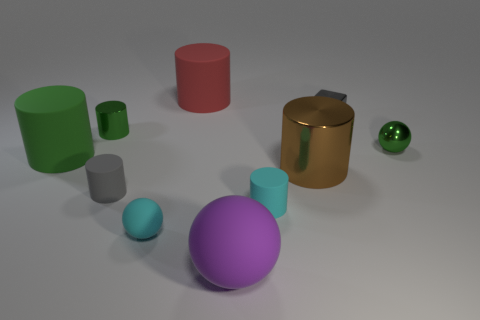Is the gray thing that is in front of the tiny gray shiny cube made of the same material as the tiny cyan object to the right of the purple sphere?
Provide a succinct answer. Yes. Is the number of tiny balls on the right side of the block greater than the number of small red metallic cylinders?
Provide a short and direct response. Yes. The big matte cylinder that is in front of the ball behind the large green thing is what color?
Keep it short and to the point. Green. There is a brown shiny thing that is the same size as the purple object; what is its shape?
Your response must be concise. Cylinder. What shape is the thing that is the same color as the tiny cube?
Provide a short and direct response. Cylinder. Are there the same number of gray cylinders that are to the right of the large purple matte sphere and shiny things?
Keep it short and to the point. No. What material is the large thing that is to the left of the small gray thing that is to the left of the gray thing that is on the right side of the tiny cyan matte sphere made of?
Your answer should be very brief. Rubber. What shape is the green object that is the same material as the large sphere?
Provide a succinct answer. Cylinder. Are there any other things of the same color as the metallic sphere?
Ensure brevity in your answer.  Yes. What number of green cylinders are to the right of the big matte cylinder that is in front of the green metal thing behind the green shiny ball?
Ensure brevity in your answer.  1. 